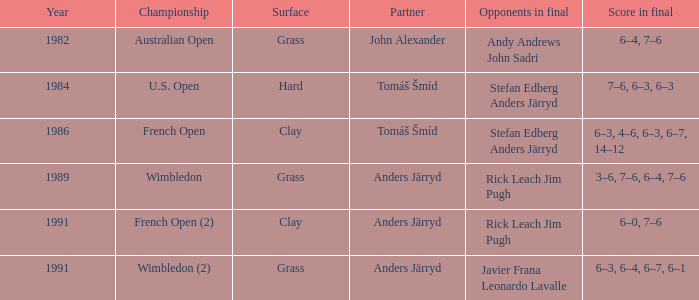Who was his teammate in 1989? Anders Järryd. 